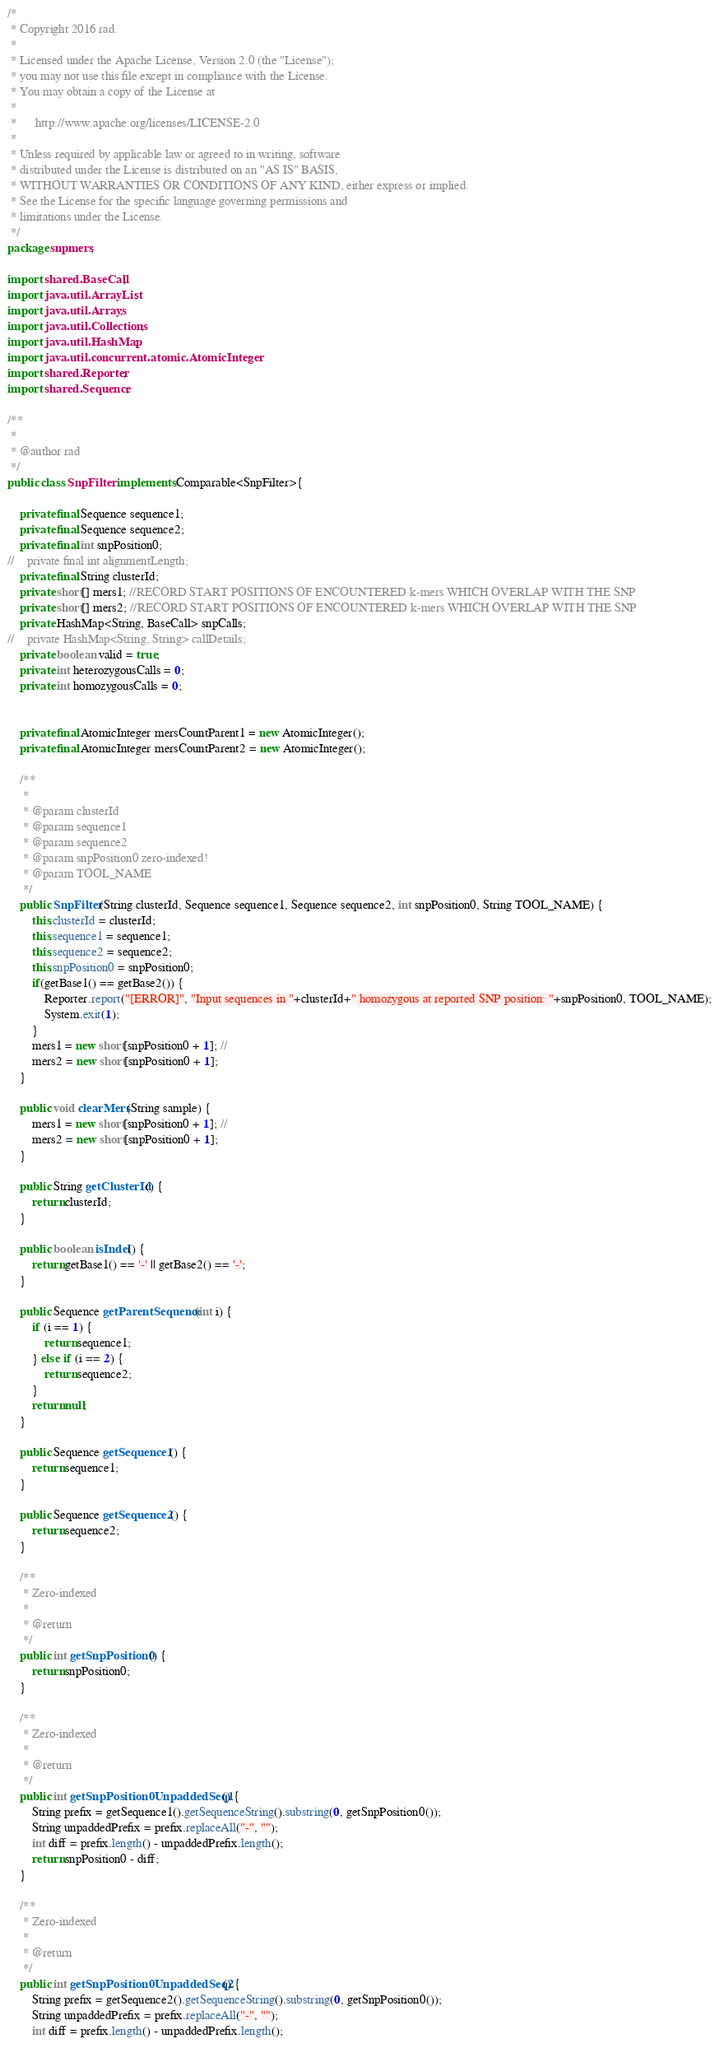Convert code to text. <code><loc_0><loc_0><loc_500><loc_500><_Java_>/*
 * Copyright 2016 rad.
 *
 * Licensed under the Apache License, Version 2.0 (the "License");
 * you may not use this file except in compliance with the License.
 * You may obtain a copy of the License at
 *
 *      http://www.apache.org/licenses/LICENSE-2.0
 *
 * Unless required by applicable law or agreed to in writing, software
 * distributed under the License is distributed on an "AS IS" BASIS,
 * WITHOUT WARRANTIES OR CONDITIONS OF ANY KIND, either express or implied.
 * See the License for the specific language governing permissions and
 * limitations under the License.
 */
package snpmers;

import shared.BaseCall;
import java.util.ArrayList;
import java.util.Arrays;
import java.util.Collections;
import java.util.HashMap;
import java.util.concurrent.atomic.AtomicInteger;
import shared.Reporter;
import shared.Sequence;

/**
 *
 * @author rad
 */
public class SnpFilter implements Comparable<SnpFilter>{

    private final Sequence sequence1;
    private final Sequence sequence2;
    private final int snpPosition0;
//    private final int alignmentLength;
    private final String clusterId;
    private short[] mers1; //RECORD START POSITIONS OF ENCOUNTERED k-mers WHICH OVERLAP WITH THE SNP
    private short[] mers2; //RECORD START POSITIONS OF ENCOUNTERED k-mers WHICH OVERLAP WITH THE SNP
    private HashMap<String, BaseCall> snpCalls;
//    private HashMap<String, String> callDetails;
    private boolean valid = true;
    private int heterozygousCalls = 0;
    private int homozygousCalls = 0;
    

    private final AtomicInteger mersCountParent1 = new AtomicInteger();
    private final AtomicInteger mersCountParent2 = new AtomicInteger();

    /**
     *
     * @param clusterId
     * @param sequence1
     * @param sequence2
     * @param snpPosition0 zero-indexed!
     * @param TOOL_NAME
     */
    public SnpFilter(String clusterId, Sequence sequence1, Sequence sequence2, int snpPosition0, String TOOL_NAME) {
        this.clusterId = clusterId;
        this.sequence1 = sequence1;
        this.sequence2 = sequence2;
        this.snpPosition0 = snpPosition0;
        if(getBase1() == getBase2()) {
            Reporter.report("[ERROR]", "Input sequences in "+clusterId+" homozygous at reported SNP position: "+snpPosition0, TOOL_NAME);
            System.exit(1);
        }
        mers1 = new short[snpPosition0 + 1]; //
        mers2 = new short[snpPosition0 + 1];
    }

    public void clearMers(String sample) {
        mers1 = new short[snpPosition0 + 1]; //
        mers2 = new short[snpPosition0 + 1];
    }

    public String getClusterId() {
        return clusterId;
    }

    public boolean isIndel() {
        return getBase1() == '-' || getBase2() == '-';
    }

    public Sequence getParentSequence(int i) {
        if (i == 1) {
            return sequence1;
        } else if (i == 2) {
            return sequence2;
        }
        return null;
    }

    public Sequence getSequence1() {
        return sequence1;
    }

    public Sequence getSequence2() {
        return sequence2;
    }

    /**
     * Zero-indexed
     *
     * @return
     */
    public int getSnpPosition0() {
        return snpPosition0;
    }

    /**
     * Zero-indexed
     *
     * @return
     */
    public int getSnpPosition0UnpaddedSeq1() {
        String prefix = getSequence1().getSequenceString().substring(0, getSnpPosition0());
        String unpaddedPrefix = prefix.replaceAll("-", "");
        int diff = prefix.length() - unpaddedPrefix.length();
        return snpPosition0 - diff;
    }

    /**
     * Zero-indexed
     *
     * @return
     */
    public int getSnpPosition0UnpaddedSeq2() {
        String prefix = getSequence2().getSequenceString().substring(0, getSnpPosition0());
        String unpaddedPrefix = prefix.replaceAll("-", "");
        int diff = prefix.length() - unpaddedPrefix.length();</code> 